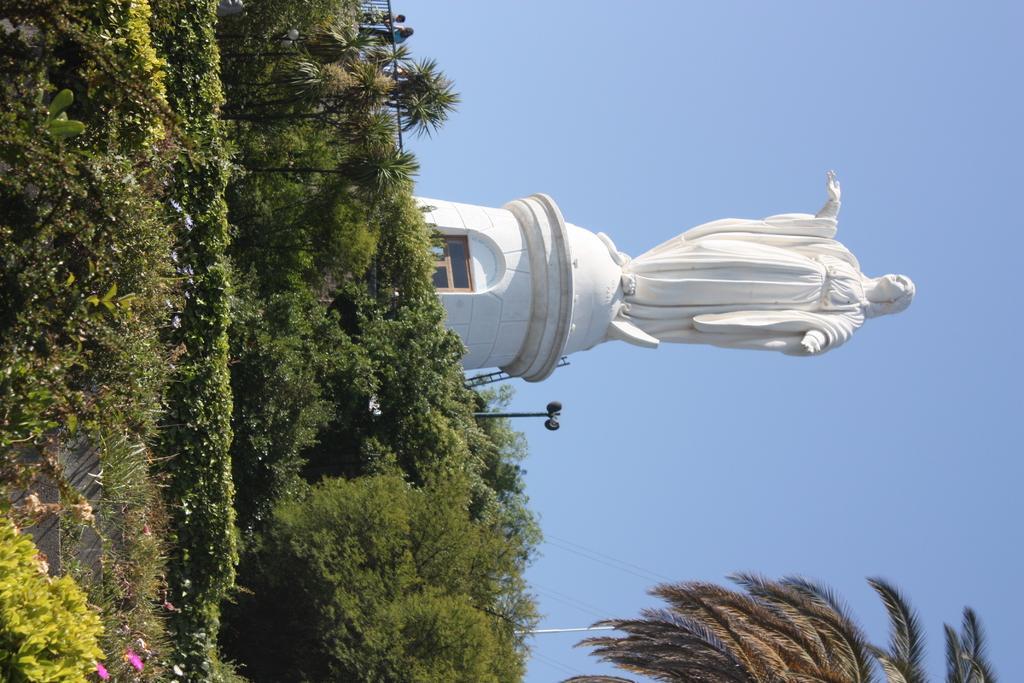Could you give a brief overview of what you see in this image? In this image in the center there are plants and there is a statue which is white in colour. 